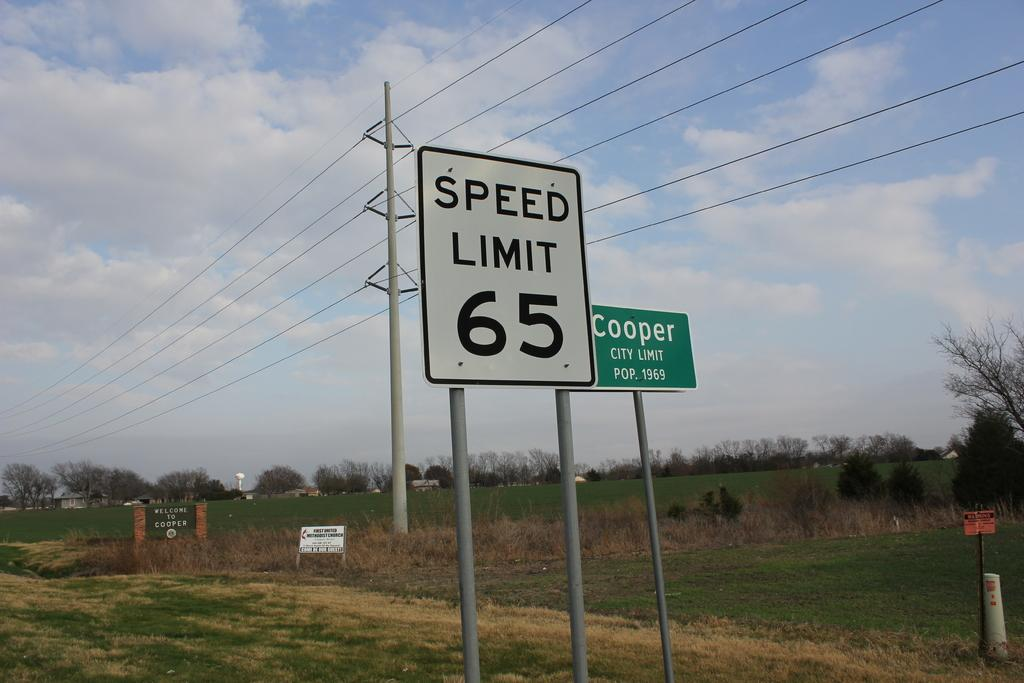<image>
Give a short and clear explanation of the subsequent image. A city limit sign saying "Cooper, city limit pop 1969 and a “speed limit 65” sign are in the foreground against a rural setting. 